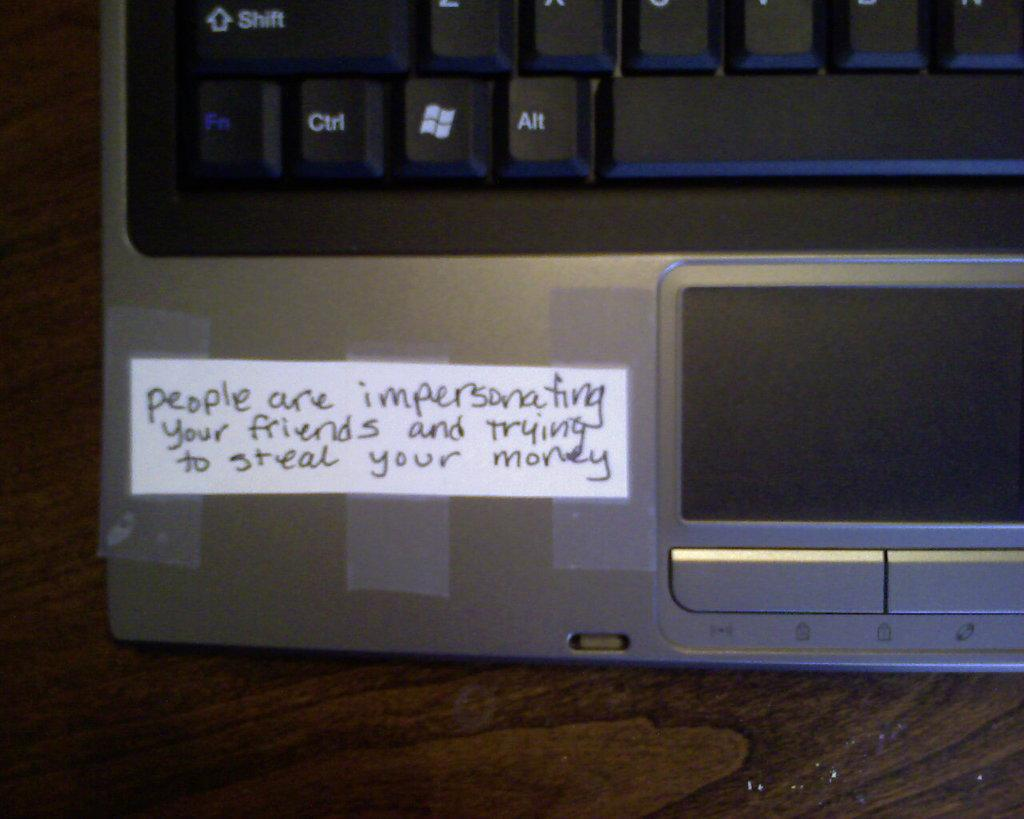What electronic device is visible in the image? There is a laptop in the image. Where is the laptop placed? The laptop is on a platform in the image. Can you describe the platform? The platform appears to be truncated in the image. What else can be seen in the image besides the laptop and platform? There is a paper with text written on it in the image. How many wishes does the laptop grant in the image? The image does not depict the laptop granting wishes, as it is an electronic device and not a magical object. 